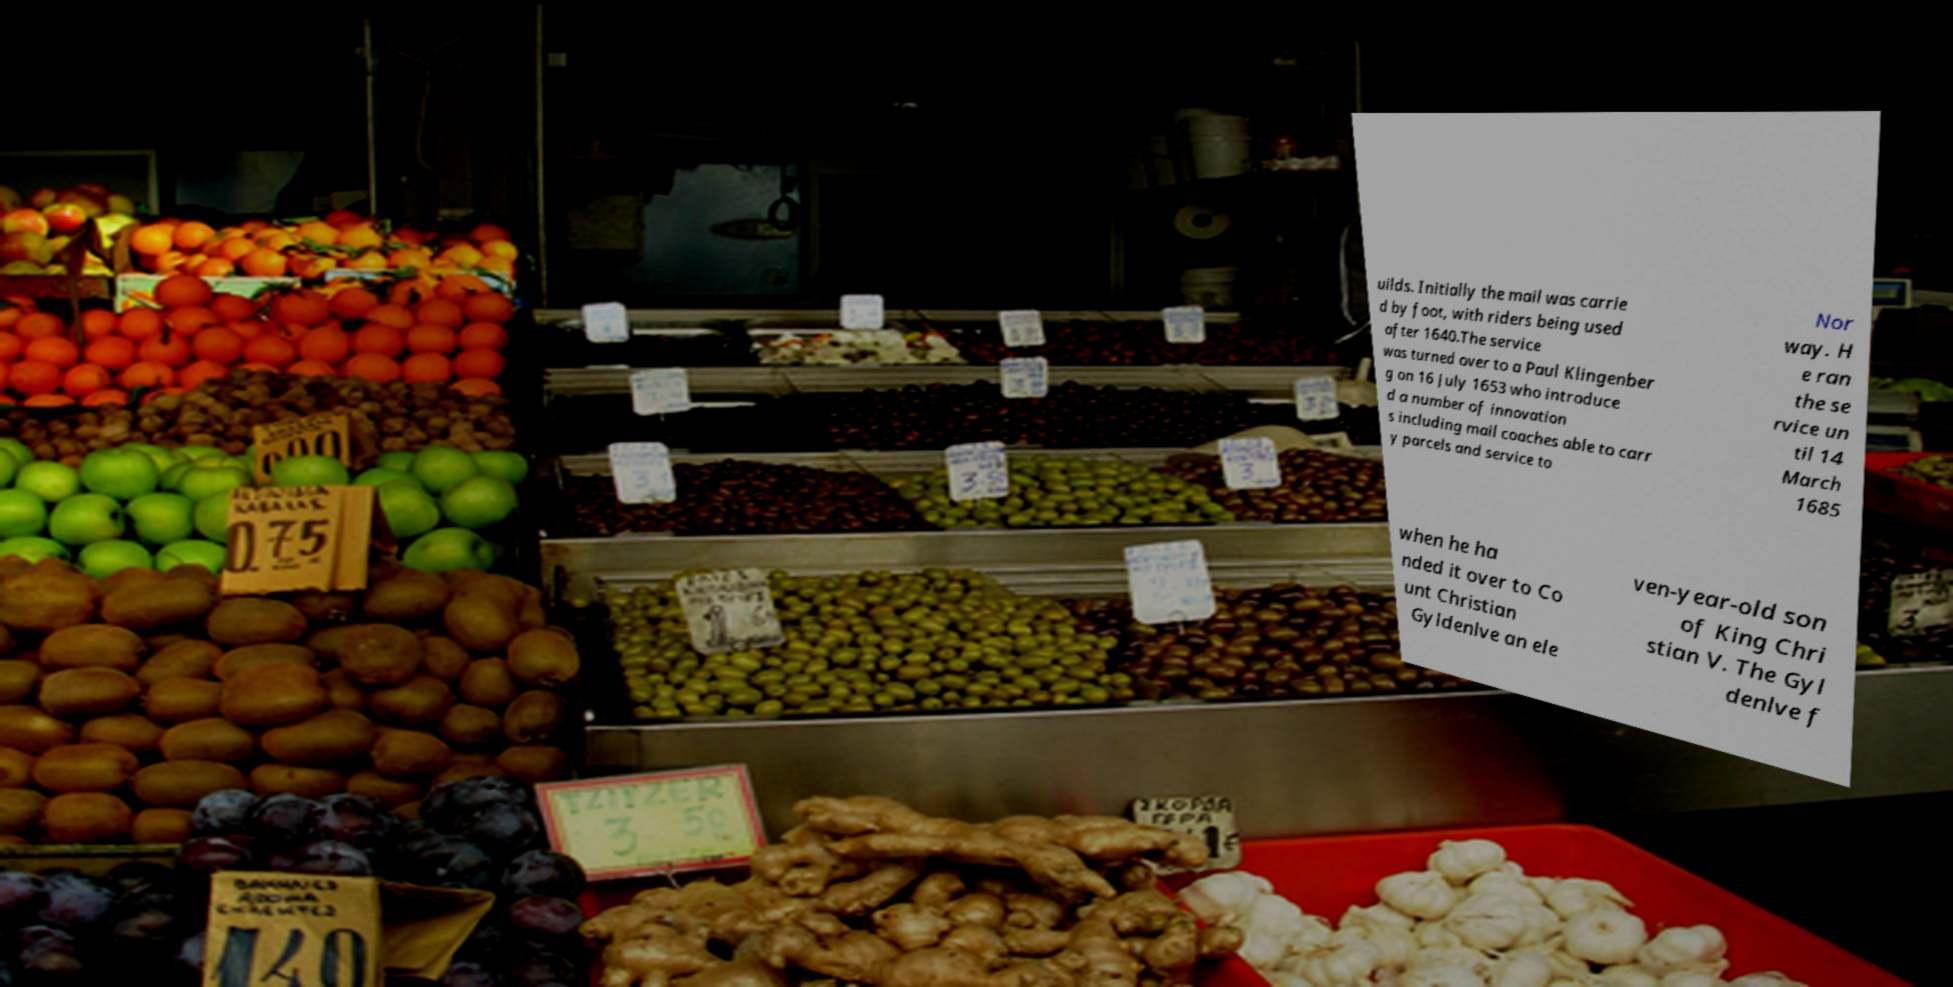Can you read and provide the text displayed in the image?This photo seems to have some interesting text. Can you extract and type it out for me? uilds. Initially the mail was carrie d by foot, with riders being used after 1640.The service was turned over to a Paul Klingenber g on 16 July 1653 who introduce d a number of innovation s including mail coaches able to carr y parcels and service to Nor way. H e ran the se rvice un til 14 March 1685 when he ha nded it over to Co unt Christian Gyldenlve an ele ven-year-old son of King Chri stian V. The Gyl denlve f 